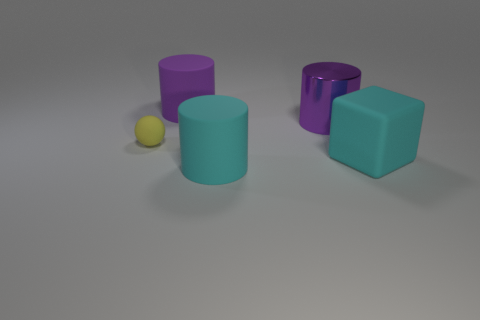What color is the small object that is the same material as the large block?
Keep it short and to the point. Yellow. There is a purple rubber object; does it have the same shape as the big purple object on the right side of the large cyan rubber cylinder?
Your answer should be very brief. Yes. There is a large thing that is the same color as the big metallic cylinder; what material is it?
Your response must be concise. Rubber. What material is the cyan cylinder that is the same size as the rubber cube?
Your answer should be very brief. Rubber. Are there any small matte balls of the same color as the large matte cube?
Offer a very short reply. No. There is a big object that is in front of the tiny yellow ball and to the left of the cyan rubber block; what shape is it?
Make the answer very short. Cylinder. How many other tiny spheres have the same material as the tiny sphere?
Provide a short and direct response. 0. Are there fewer large cyan cubes in front of the big cyan matte cylinder than large cyan cubes behind the small rubber ball?
Provide a short and direct response. No. There is a purple cylinder that is on the left side of the purple thing in front of the rubber cylinder behind the block; what is its material?
Keep it short and to the point. Rubber. There is a object that is both right of the big cyan cylinder and in front of the big shiny thing; what is its size?
Give a very brief answer. Large. 